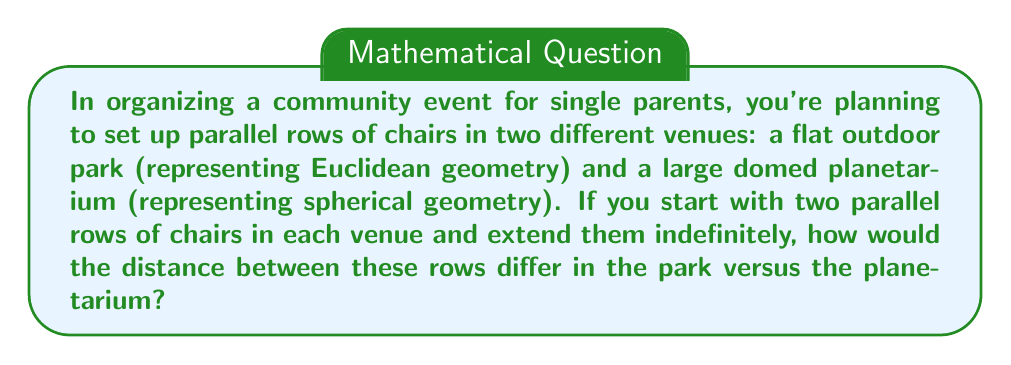Help me with this question. Let's approach this step-by-step:

1. Euclidean Geometry (Park):
   In Euclidean geometry, parallel lines are defined as lines in the same plane that never intersect, no matter how far they are extended.
   
   $$ d_E = \text{constant} $$
   
   Where $d_E$ is the distance between parallel lines in Euclidean geometry.

2. Spherical Geometry (Planetarium):
   In spherical geometry, "parallel" lines are great circles that intersect at two antipodal points.
   
   The distance between these lines varies as we move along them:
   
   $$ d_S = R \cdot \sin(\theta) $$
   
   Where:
   - $d_S$ is the distance between "parallel" lines in spherical geometry
   - $R$ is the radius of the sphere
   - $\theta$ is the angle between the lines at their intersection point

3. Comparison:
   - In the park (Euclidean): The distance between the rows remains constant.
   - In the planetarium (Spherical): The distance starts at zero at the intersection points, increases to a maximum at the "equator" (halfway between intersections), then decreases back to zero.

[asy]
import geometry;

size(200);

// Euclidean
draw((0,0)--(100,0), blue);
draw((0,20)--(100,20), blue);
label("Euclidean", (50,-10), blue);

// Spherical
path c1=Circle((0,70),30);
path c2=Circle((0,70),30,180,360);
draw(c1, red);
draw(c2, red);
label("Spherical", (0,110), red);

draw((30,70)--(30,100), dashed);
draw((-30,70)--(-30,100), dashed);
</asy]
Answer: In Euclidean geometry (park), the distance remains constant; in spherical geometry (planetarium), the distance varies, starting and ending at zero with a maximum in between. 